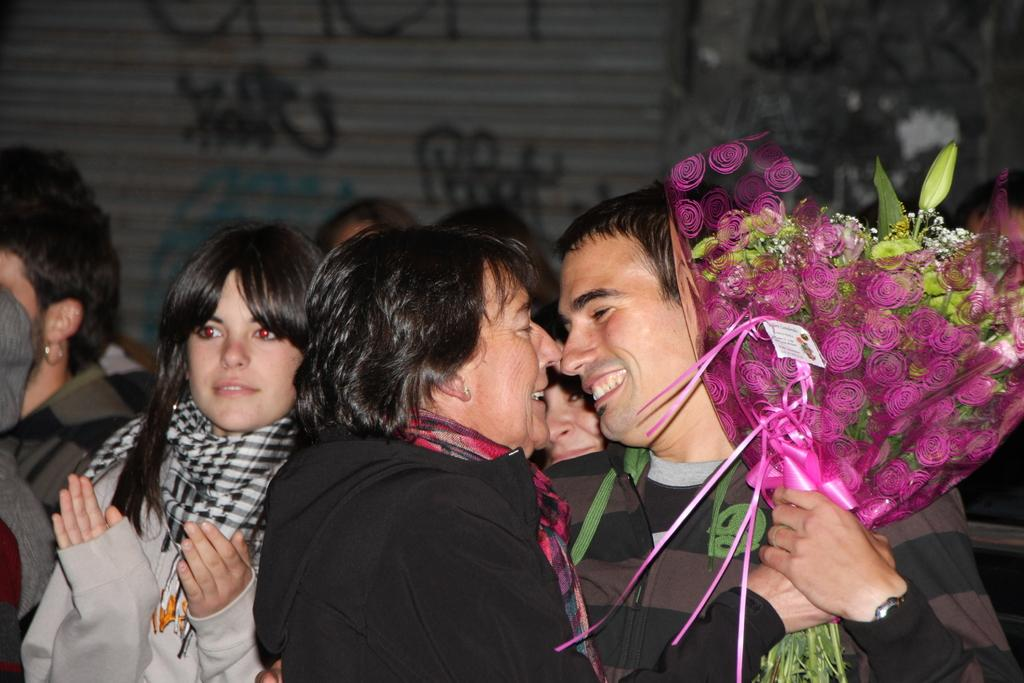How many people are in the foreground of the picture? There are two people, a man and a woman, in the foreground of the picture. What is the woman holding in the picture? The woman is holding a bouquet. What can be seen in the background of the picture? There are persons standing in the background of the picture, and there is a shatter. How many bees are buzzing around the lamp in the image? There is no lamp or bees present in the image. What is the amount of money the couple is holding in the image? There is no indication of money being held by the couple in the image. 